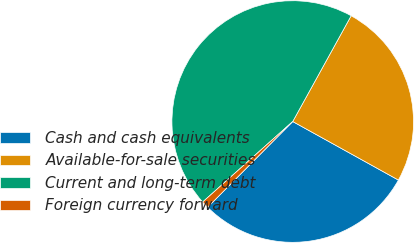Convert chart to OTSL. <chart><loc_0><loc_0><loc_500><loc_500><pie_chart><fcel>Cash and cash equivalents<fcel>Available-for-sale securities<fcel>Current and long-term debt<fcel>Foreign currency forward<nl><fcel>29.39%<fcel>25.02%<fcel>44.64%<fcel>0.95%<nl></chart> 